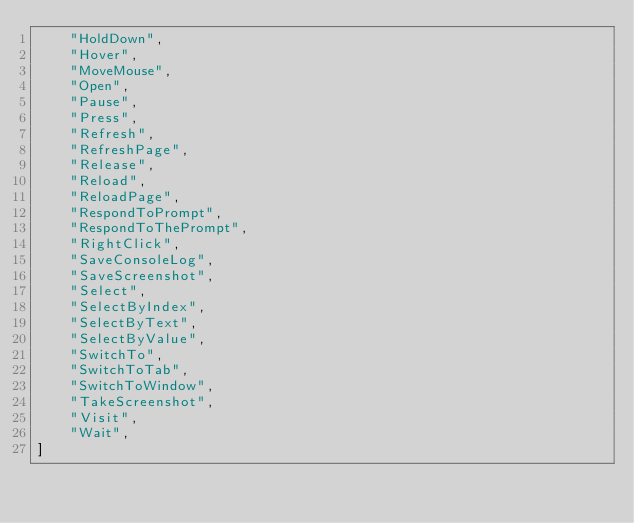<code> <loc_0><loc_0><loc_500><loc_500><_Python_>    "HoldDown",
    "Hover",
    "MoveMouse",
    "Open",
    "Pause",
    "Press",
    "Refresh",
    "RefreshPage",
    "Release",
    "Reload",
    "ReloadPage",
    "RespondToPrompt",
    "RespondToThePrompt",
    "RightClick",
    "SaveConsoleLog",
    "SaveScreenshot",
    "Select",
    "SelectByIndex",
    "SelectByText",
    "SelectByValue",
    "SwitchTo",
    "SwitchToTab",
    "SwitchToWindow",
    "TakeScreenshot",
    "Visit",
    "Wait",
]
</code> 